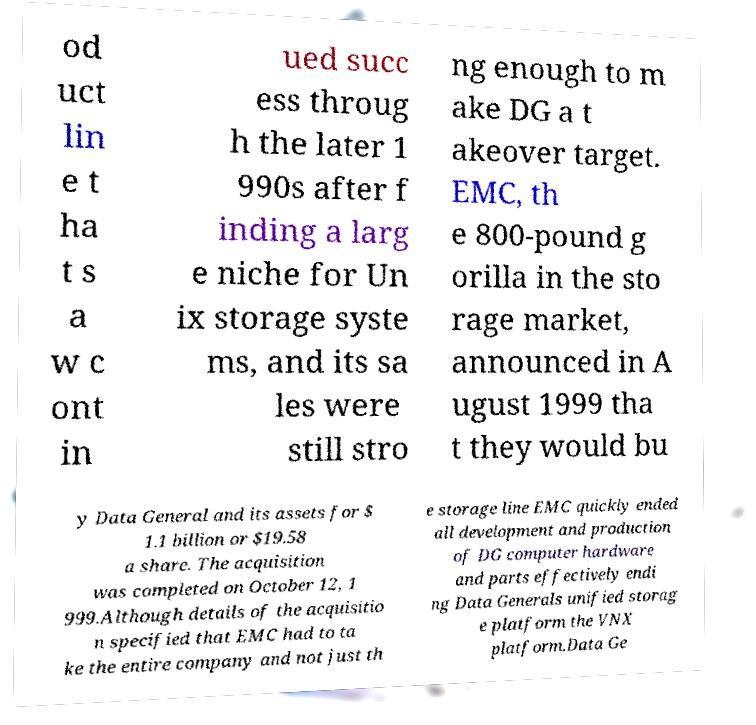Can you read and provide the text displayed in the image?This photo seems to have some interesting text. Can you extract and type it out for me? od uct lin e t ha t s a w c ont in ued succ ess throug h the later 1 990s after f inding a larg e niche for Un ix storage syste ms, and its sa les were still stro ng enough to m ake DG a t akeover target. EMC, th e 800-pound g orilla in the sto rage market, announced in A ugust 1999 tha t they would bu y Data General and its assets for $ 1.1 billion or $19.58 a share. The acquisition was completed on October 12, 1 999.Although details of the acquisitio n specified that EMC had to ta ke the entire company and not just th e storage line EMC quickly ended all development and production of DG computer hardware and parts effectively endi ng Data Generals unified storag e platform the VNX platform.Data Ge 